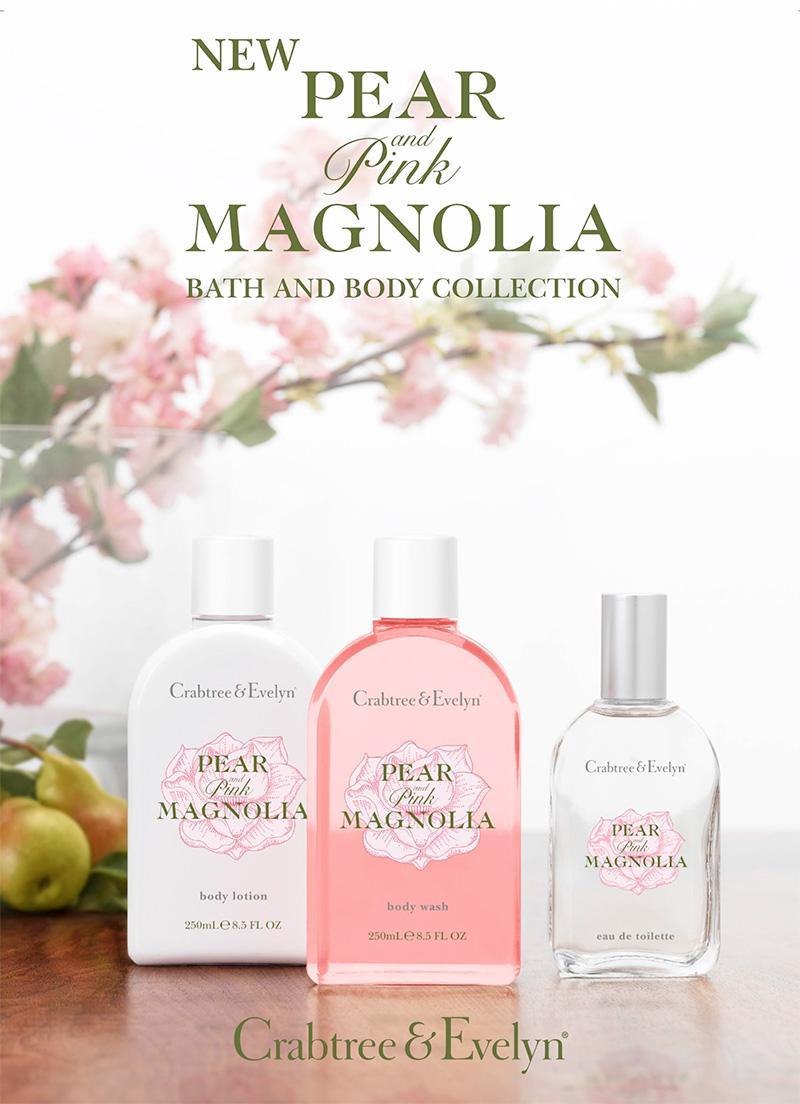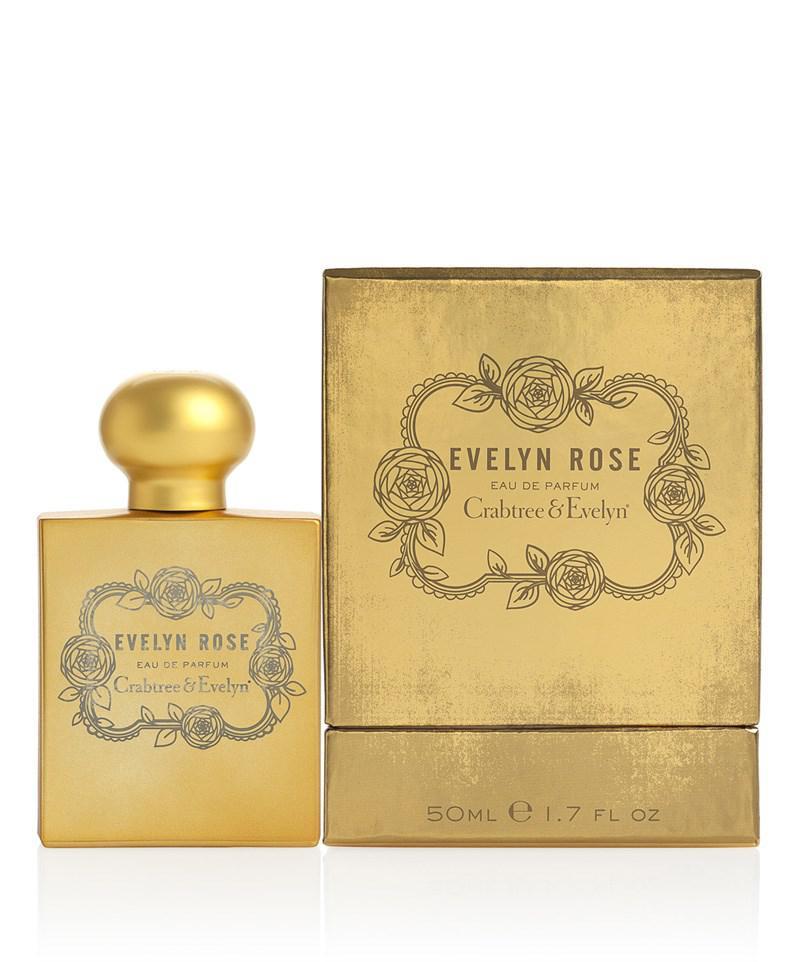The first image is the image on the left, the second image is the image on the right. Analyze the images presented: Is the assertion "there are two perfume bottles in the image pair" valid? Answer yes or no. No. The first image is the image on the left, the second image is the image on the right. Given the left and right images, does the statement "In the image to the right, the fragrance bottle is a different color than its box." hold true? Answer yes or no. No. 